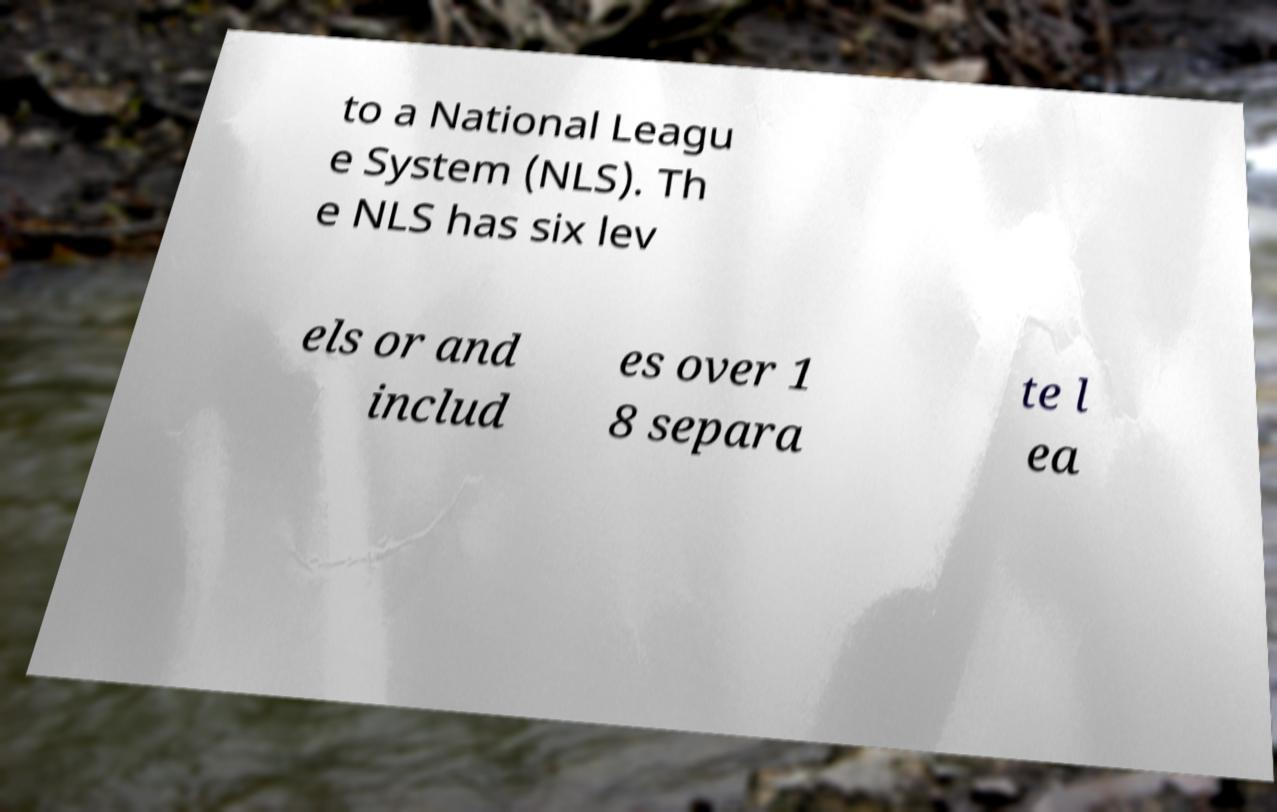Please read and relay the text visible in this image. What does it say? to a National Leagu e System (NLS). Th e NLS has six lev els or and includ es over 1 8 separa te l ea 